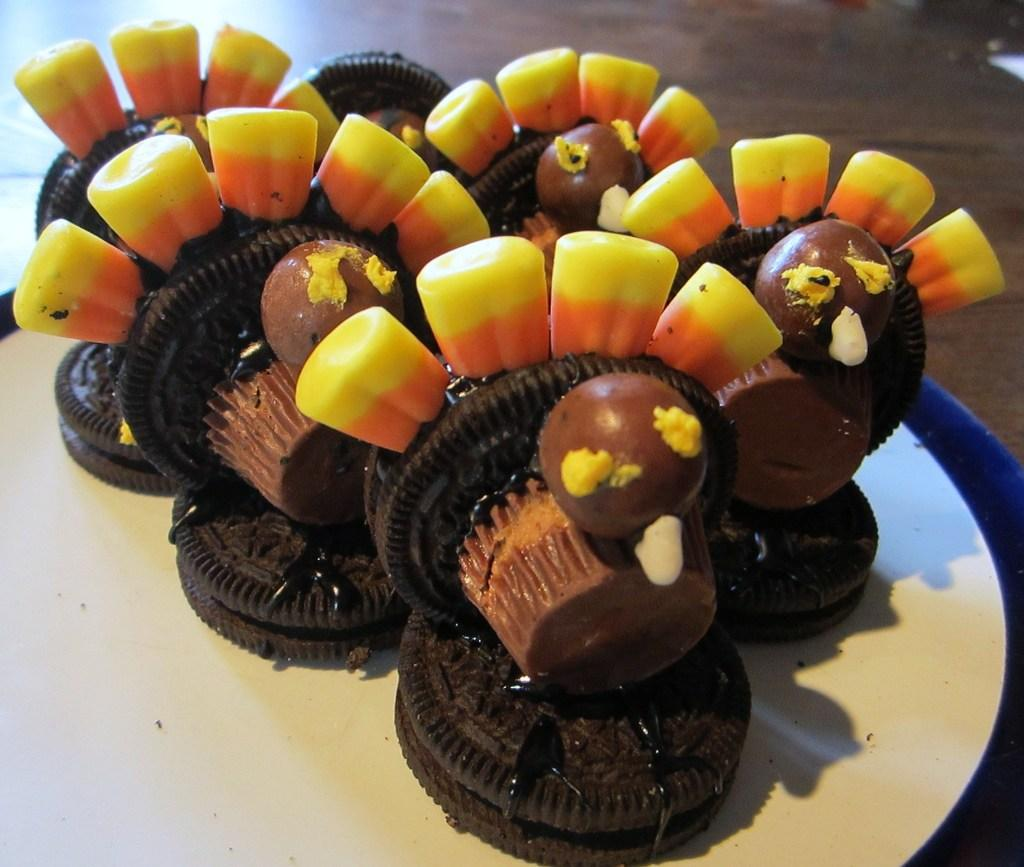What type of food items can be seen on the table in the image? There are biscuits on the table in the image. What other sweet treats are visible in the image? There are cupcakes and chocolate balls in the image. What color is the van parked on the sidewalk in the image? There is no van or sidewalk present in the image; it only features biscuits, cupcakes, and chocolate balls. 